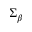<formula> <loc_0><loc_0><loc_500><loc_500>\Sigma _ { \beta }</formula> 